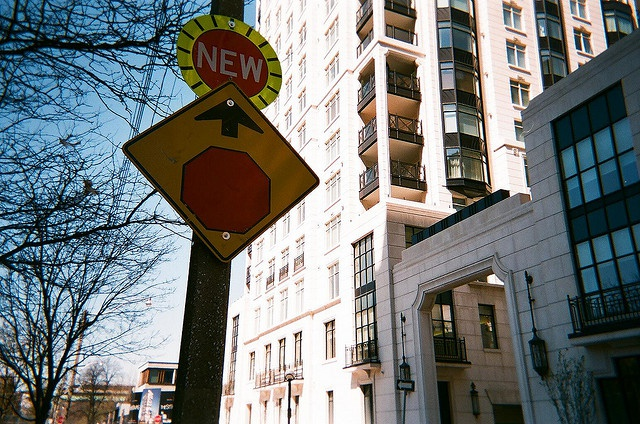Describe the objects in this image and their specific colors. I can see people in teal, black, tan, and gray tones, stop sign in teal, lightpink, salmon, tan, and brown tones, people in teal, tan, brown, darkgray, and lightgray tones, and stop sign in teal and brown tones in this image. 